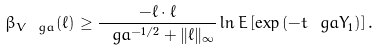Convert formula to latex. <formula><loc_0><loc_0><loc_500><loc_500>\beta _ { V _ { \ } g a } ( \ell ) \geq \frac { - \ell \cdot \ell } { \ g a ^ { - 1 / 2 } + \| \ell \| _ { \infty } } \ln E \left [ \exp \left ( - t \ g a Y _ { 1 } \right ) \right ] .</formula> 